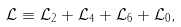<formula> <loc_0><loc_0><loc_500><loc_500>\mathcal { L } \equiv \mathcal { L } _ { 2 } + \mathcal { L } _ { 4 } + \mathcal { L } _ { 6 } + \mathcal { L } _ { 0 } ,</formula> 